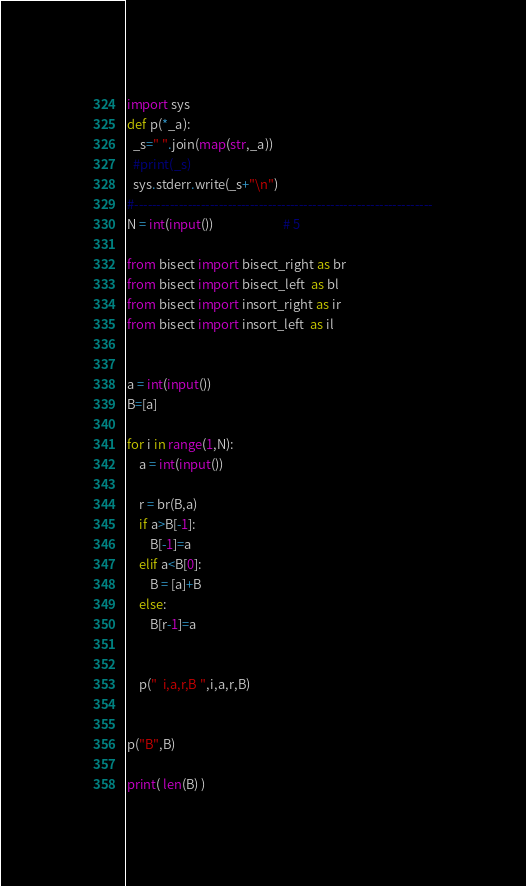<code> <loc_0><loc_0><loc_500><loc_500><_Python_>import sys
def p(*_a):
  _s=" ".join(map(str,_a))
  #print(_s)
  sys.stderr.write(_s+"\n")
#-------------------------------------------------------------------
N = int(input())						# 5

from bisect import bisect_right as br
from bisect import bisect_left  as bl
from bisect import insort_right as ir
from bisect import insort_left  as il


a = int(input())
B=[a]

for i in range(1,N):
	a = int(input())

	r = br(B,a)
	if a>B[-1]:
		B[-1]=a
	elif a<B[0]:
		B = [a]+B
	else:
		B[r-1]=a


	p("  i,a,r,B ",i,a,r,B)


p("B",B)

print( len(B) )
</code> 